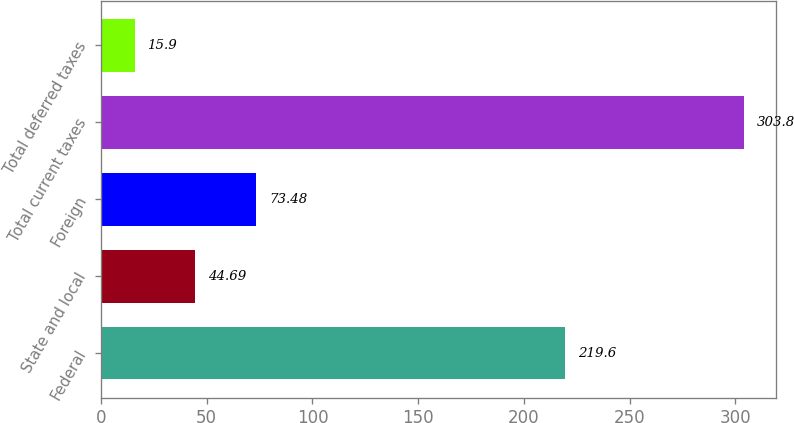Convert chart to OTSL. <chart><loc_0><loc_0><loc_500><loc_500><bar_chart><fcel>Federal<fcel>State and local<fcel>Foreign<fcel>Total current taxes<fcel>Total deferred taxes<nl><fcel>219.6<fcel>44.69<fcel>73.48<fcel>303.8<fcel>15.9<nl></chart> 